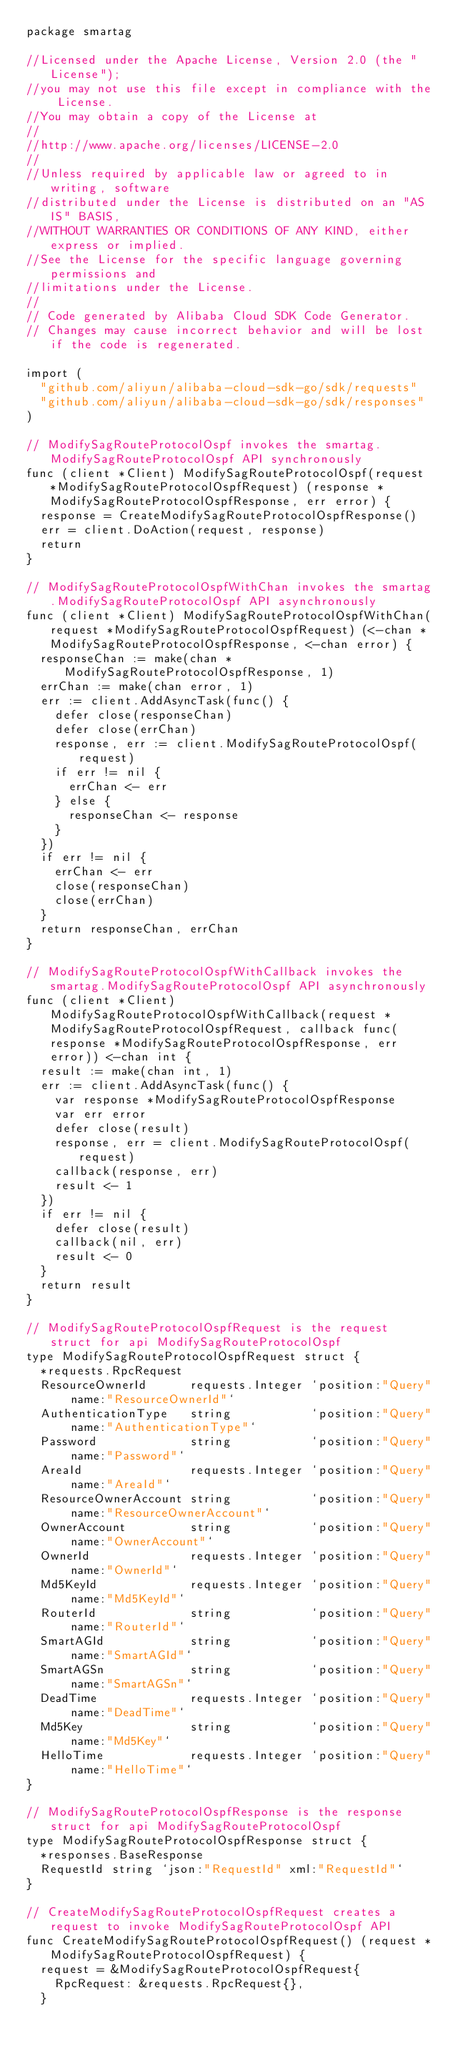<code> <loc_0><loc_0><loc_500><loc_500><_Go_>package smartag

//Licensed under the Apache License, Version 2.0 (the "License");
//you may not use this file except in compliance with the License.
//You may obtain a copy of the License at
//
//http://www.apache.org/licenses/LICENSE-2.0
//
//Unless required by applicable law or agreed to in writing, software
//distributed under the License is distributed on an "AS IS" BASIS,
//WITHOUT WARRANTIES OR CONDITIONS OF ANY KIND, either express or implied.
//See the License for the specific language governing permissions and
//limitations under the License.
//
// Code generated by Alibaba Cloud SDK Code Generator.
// Changes may cause incorrect behavior and will be lost if the code is regenerated.

import (
	"github.com/aliyun/alibaba-cloud-sdk-go/sdk/requests"
	"github.com/aliyun/alibaba-cloud-sdk-go/sdk/responses"
)

// ModifySagRouteProtocolOspf invokes the smartag.ModifySagRouteProtocolOspf API synchronously
func (client *Client) ModifySagRouteProtocolOspf(request *ModifySagRouteProtocolOspfRequest) (response *ModifySagRouteProtocolOspfResponse, err error) {
	response = CreateModifySagRouteProtocolOspfResponse()
	err = client.DoAction(request, response)
	return
}

// ModifySagRouteProtocolOspfWithChan invokes the smartag.ModifySagRouteProtocolOspf API asynchronously
func (client *Client) ModifySagRouteProtocolOspfWithChan(request *ModifySagRouteProtocolOspfRequest) (<-chan *ModifySagRouteProtocolOspfResponse, <-chan error) {
	responseChan := make(chan *ModifySagRouteProtocolOspfResponse, 1)
	errChan := make(chan error, 1)
	err := client.AddAsyncTask(func() {
		defer close(responseChan)
		defer close(errChan)
		response, err := client.ModifySagRouteProtocolOspf(request)
		if err != nil {
			errChan <- err
		} else {
			responseChan <- response
		}
	})
	if err != nil {
		errChan <- err
		close(responseChan)
		close(errChan)
	}
	return responseChan, errChan
}

// ModifySagRouteProtocolOspfWithCallback invokes the smartag.ModifySagRouteProtocolOspf API asynchronously
func (client *Client) ModifySagRouteProtocolOspfWithCallback(request *ModifySagRouteProtocolOspfRequest, callback func(response *ModifySagRouteProtocolOspfResponse, err error)) <-chan int {
	result := make(chan int, 1)
	err := client.AddAsyncTask(func() {
		var response *ModifySagRouteProtocolOspfResponse
		var err error
		defer close(result)
		response, err = client.ModifySagRouteProtocolOspf(request)
		callback(response, err)
		result <- 1
	})
	if err != nil {
		defer close(result)
		callback(nil, err)
		result <- 0
	}
	return result
}

// ModifySagRouteProtocolOspfRequest is the request struct for api ModifySagRouteProtocolOspf
type ModifySagRouteProtocolOspfRequest struct {
	*requests.RpcRequest
	ResourceOwnerId      requests.Integer `position:"Query" name:"ResourceOwnerId"`
	AuthenticationType   string           `position:"Query" name:"AuthenticationType"`
	Password             string           `position:"Query" name:"Password"`
	AreaId               requests.Integer `position:"Query" name:"AreaId"`
	ResourceOwnerAccount string           `position:"Query" name:"ResourceOwnerAccount"`
	OwnerAccount         string           `position:"Query" name:"OwnerAccount"`
	OwnerId              requests.Integer `position:"Query" name:"OwnerId"`
	Md5KeyId             requests.Integer `position:"Query" name:"Md5KeyId"`
	RouterId             string           `position:"Query" name:"RouterId"`
	SmartAGId            string           `position:"Query" name:"SmartAGId"`
	SmartAGSn            string           `position:"Query" name:"SmartAGSn"`
	DeadTime             requests.Integer `position:"Query" name:"DeadTime"`
	Md5Key               string           `position:"Query" name:"Md5Key"`
	HelloTime            requests.Integer `position:"Query" name:"HelloTime"`
}

// ModifySagRouteProtocolOspfResponse is the response struct for api ModifySagRouteProtocolOspf
type ModifySagRouteProtocolOspfResponse struct {
	*responses.BaseResponse
	RequestId string `json:"RequestId" xml:"RequestId"`
}

// CreateModifySagRouteProtocolOspfRequest creates a request to invoke ModifySagRouteProtocolOspf API
func CreateModifySagRouteProtocolOspfRequest() (request *ModifySagRouteProtocolOspfRequest) {
	request = &ModifySagRouteProtocolOspfRequest{
		RpcRequest: &requests.RpcRequest{},
	}</code> 